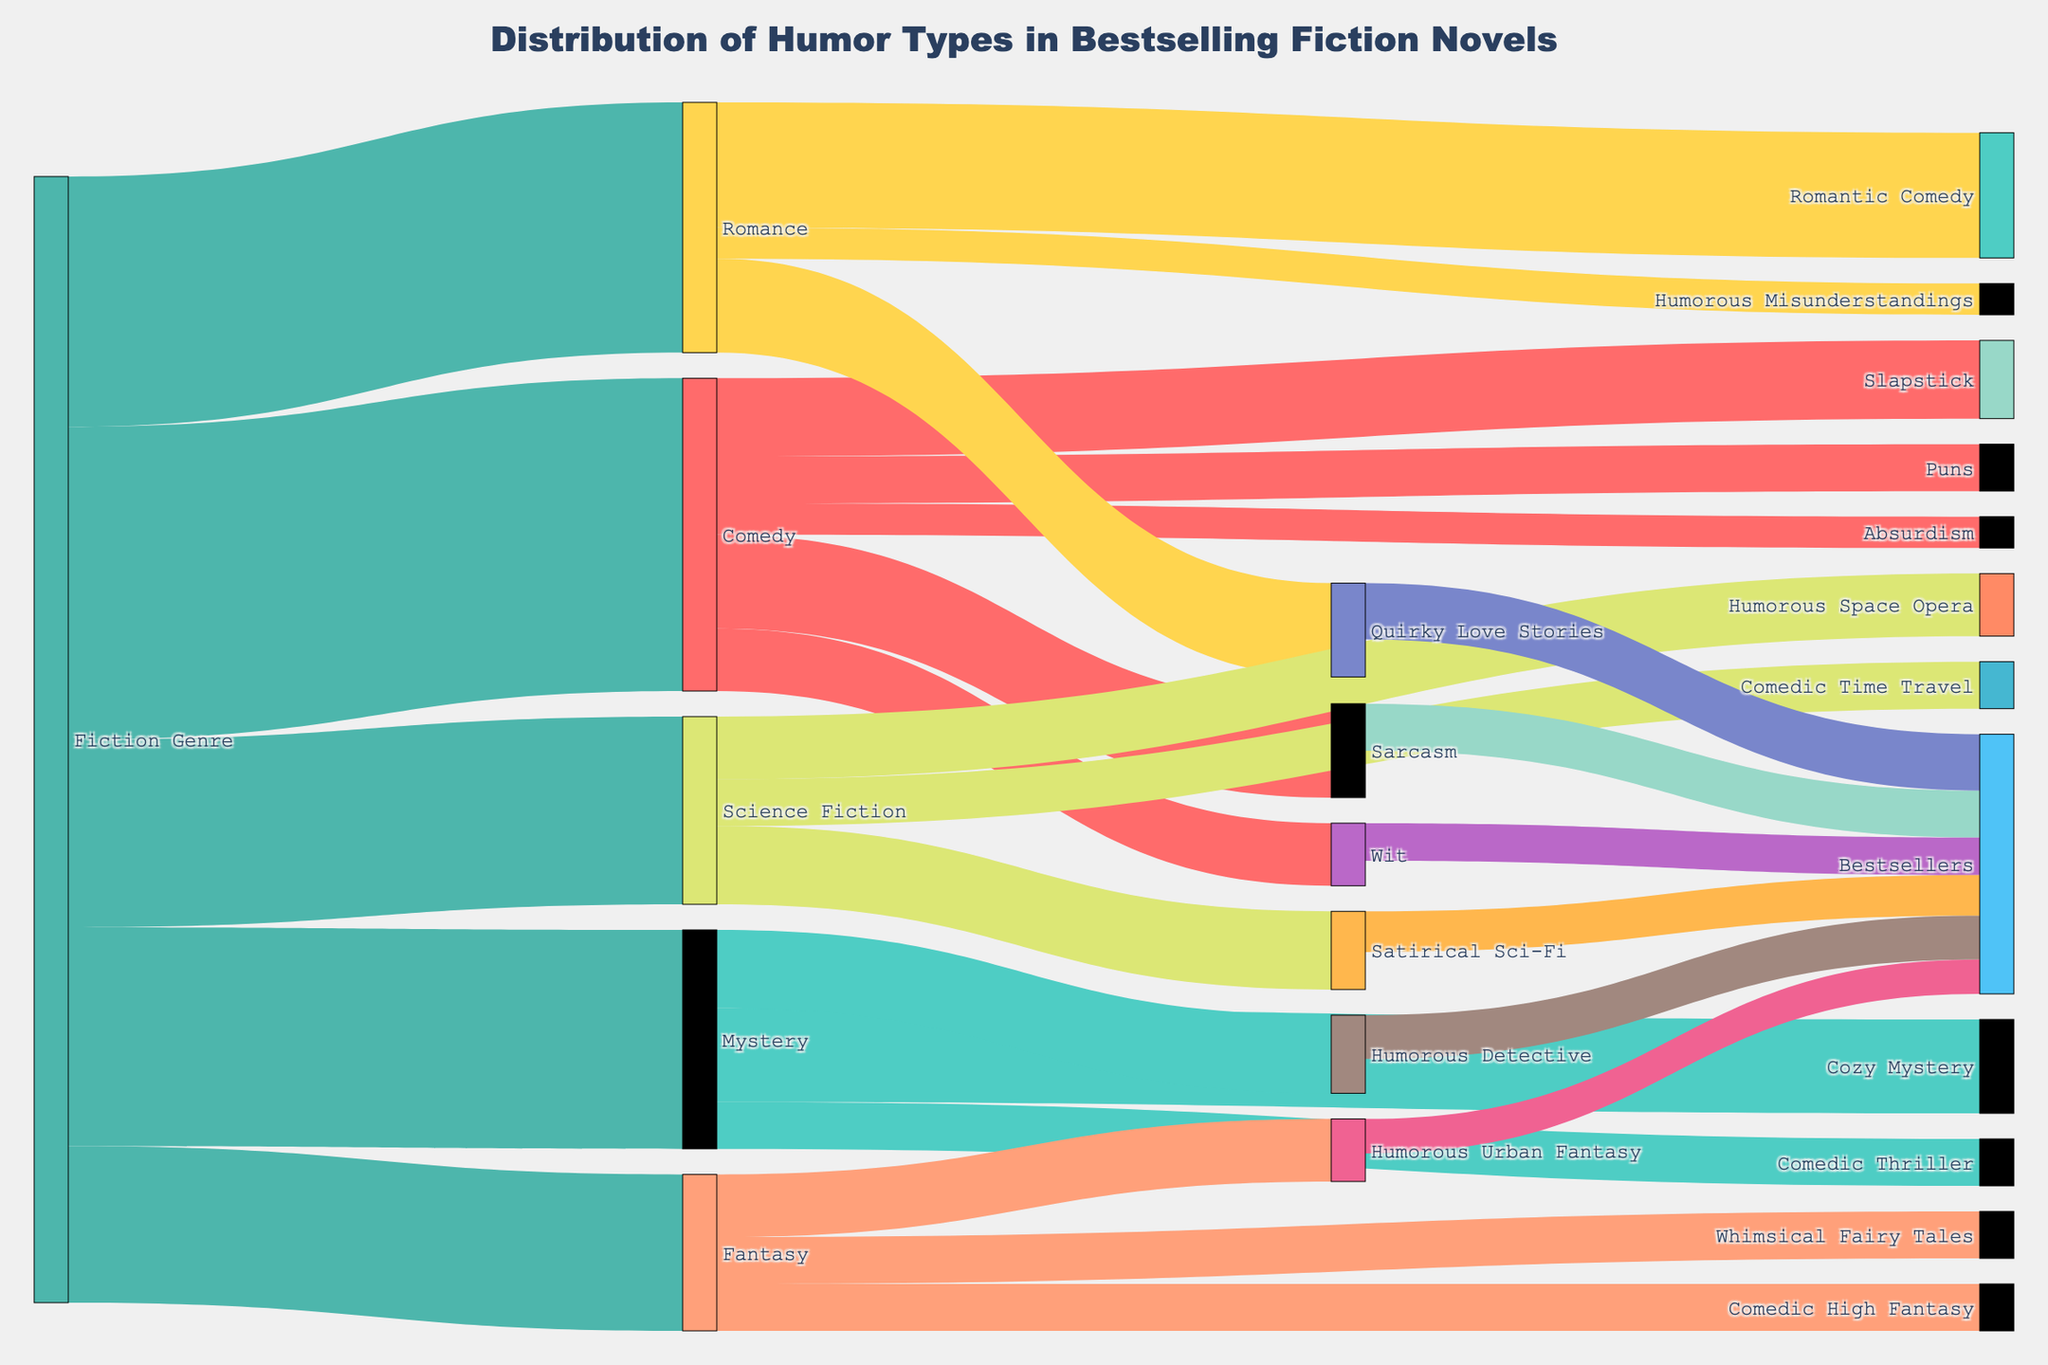What is the title of the figure? The title can be found at the top of the figure. It reads, "Distribution of Humor Types in Bestselling Fiction Novels".
Answer: Distribution of Humor Types in Bestselling Fiction Novels Which genre has the highest value in the figure? By looking at the first level of the Sankey Diagram, the genre with the highest value is "Comedy" with a value of 100.
Answer: Comedy How many subgenres does the "Mystery" genre have and what are their names? By following the links from "Mystery", we can see it connects to three subgenres: "Cozy Mystery", "Humorous Detective", and "Comedic Thriller".
Answer: Three: Cozy Mystery, Humorous Detective, Comedic Thriller What is the total value flowing into "Bestsellers" from humor types? Following all the paths that end at "Bestsellers", we find the values from "Sarcasm" (15), "Wit" (12), "Quirky Love Stories" (18), "Humorous Detective" (14), "Satirical Sci-Fi" (13), and "Humorous Urban Fantasy" (11). Summing these up gives 15 + 12 + 18 + 14 + 13 + 11 = 83.
Answer: 83 How does the value of "Sarcasm" compare to the value of "Puns"? The value of "Sarcasm" is 30 and the value of "Puns" is 15 such that the value of "Sarcasm" is double that of "Puns".
Answer: Sarcasm is double Puns Which specific humor type under "Romance" has the highest value? Under "Romance", the humor categories are "Romantic Comedy" (40), "Quirky Love Stories" (30), and "Humorous Misunderstandings" (10). The highest value among these is "Romantic Comedy" with 40.
Answer: Romantic Comedy Among the genres listed, which has the least number of humor subgenres, and what are they? The genre "Fantasy" connects to three humor subgenres: "Humorous Urban Fantasy", "Comedic High Fantasy", and "Whimsical Fairy Tales", which is the least along with "Science Fiction" having the same number.
Answer: Fantasy and Science Fiction Which humor category is shared among both "Science Fiction" and "Fantasy" and what are their values? The humor categories for "Science Fiction" are "Satirical Sci-Fi", "Humorous Space Opera", and "Comedic Time Travel", and for "Fantasy" are "Humorous Urban Fantasy", "Comedic High Fantasy", and "Whimsical Fairy Tales". None of these categories overlap.
Answer: None What is the combined value of humor categories under "Comedy"? Summing the values of "Sarcasm" (30), "Slapstick" (25), "Wit" (20), "Puns" (15), and "Absurdism" (10) for "Comedy" gives 30 + 25 + 20 + 15 + 10 = 100.
Answer: 100 In "Fiction Genre", which genre has the highest flow to Bestsellers? To find this, look at the paths ending in "Bestsellers" and track back to the genre. The highest values contributing to "Bestsellers" are in "Comedy" (Sarcasm 15, Wit 12), "Romance" (Quirky Love Stories 18), etc. Among these, "Romance" has the highest individual flow to Bestsellers via "Quirky Love Stories".
Answer: Romance 